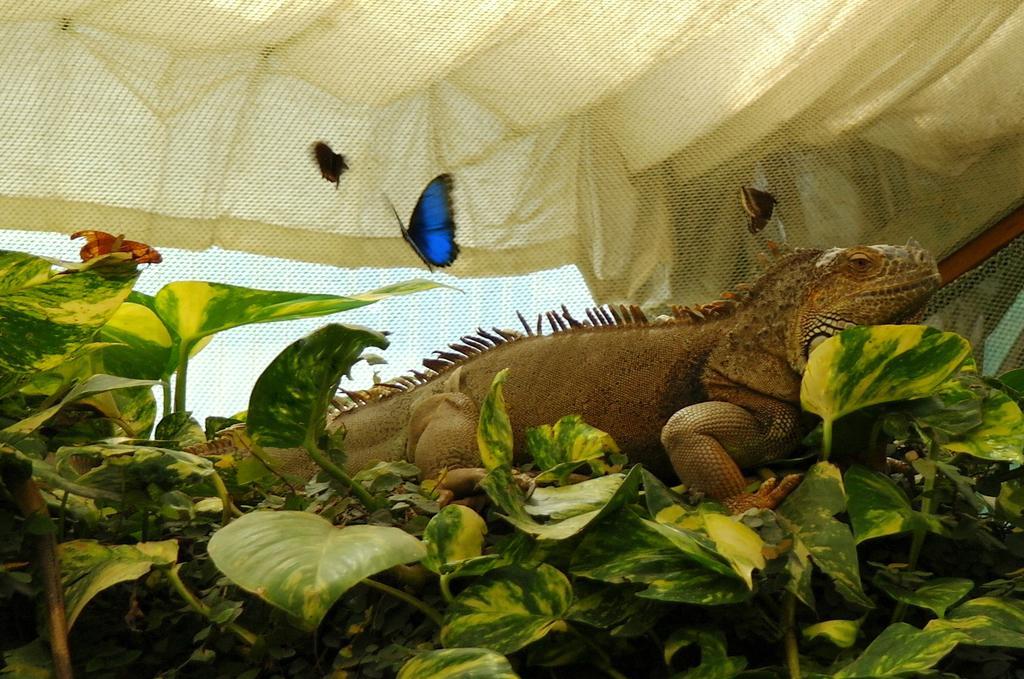Could you give a brief overview of what you see in this image? In this image we can see butterflies, iguana, plants, flower and a net. 